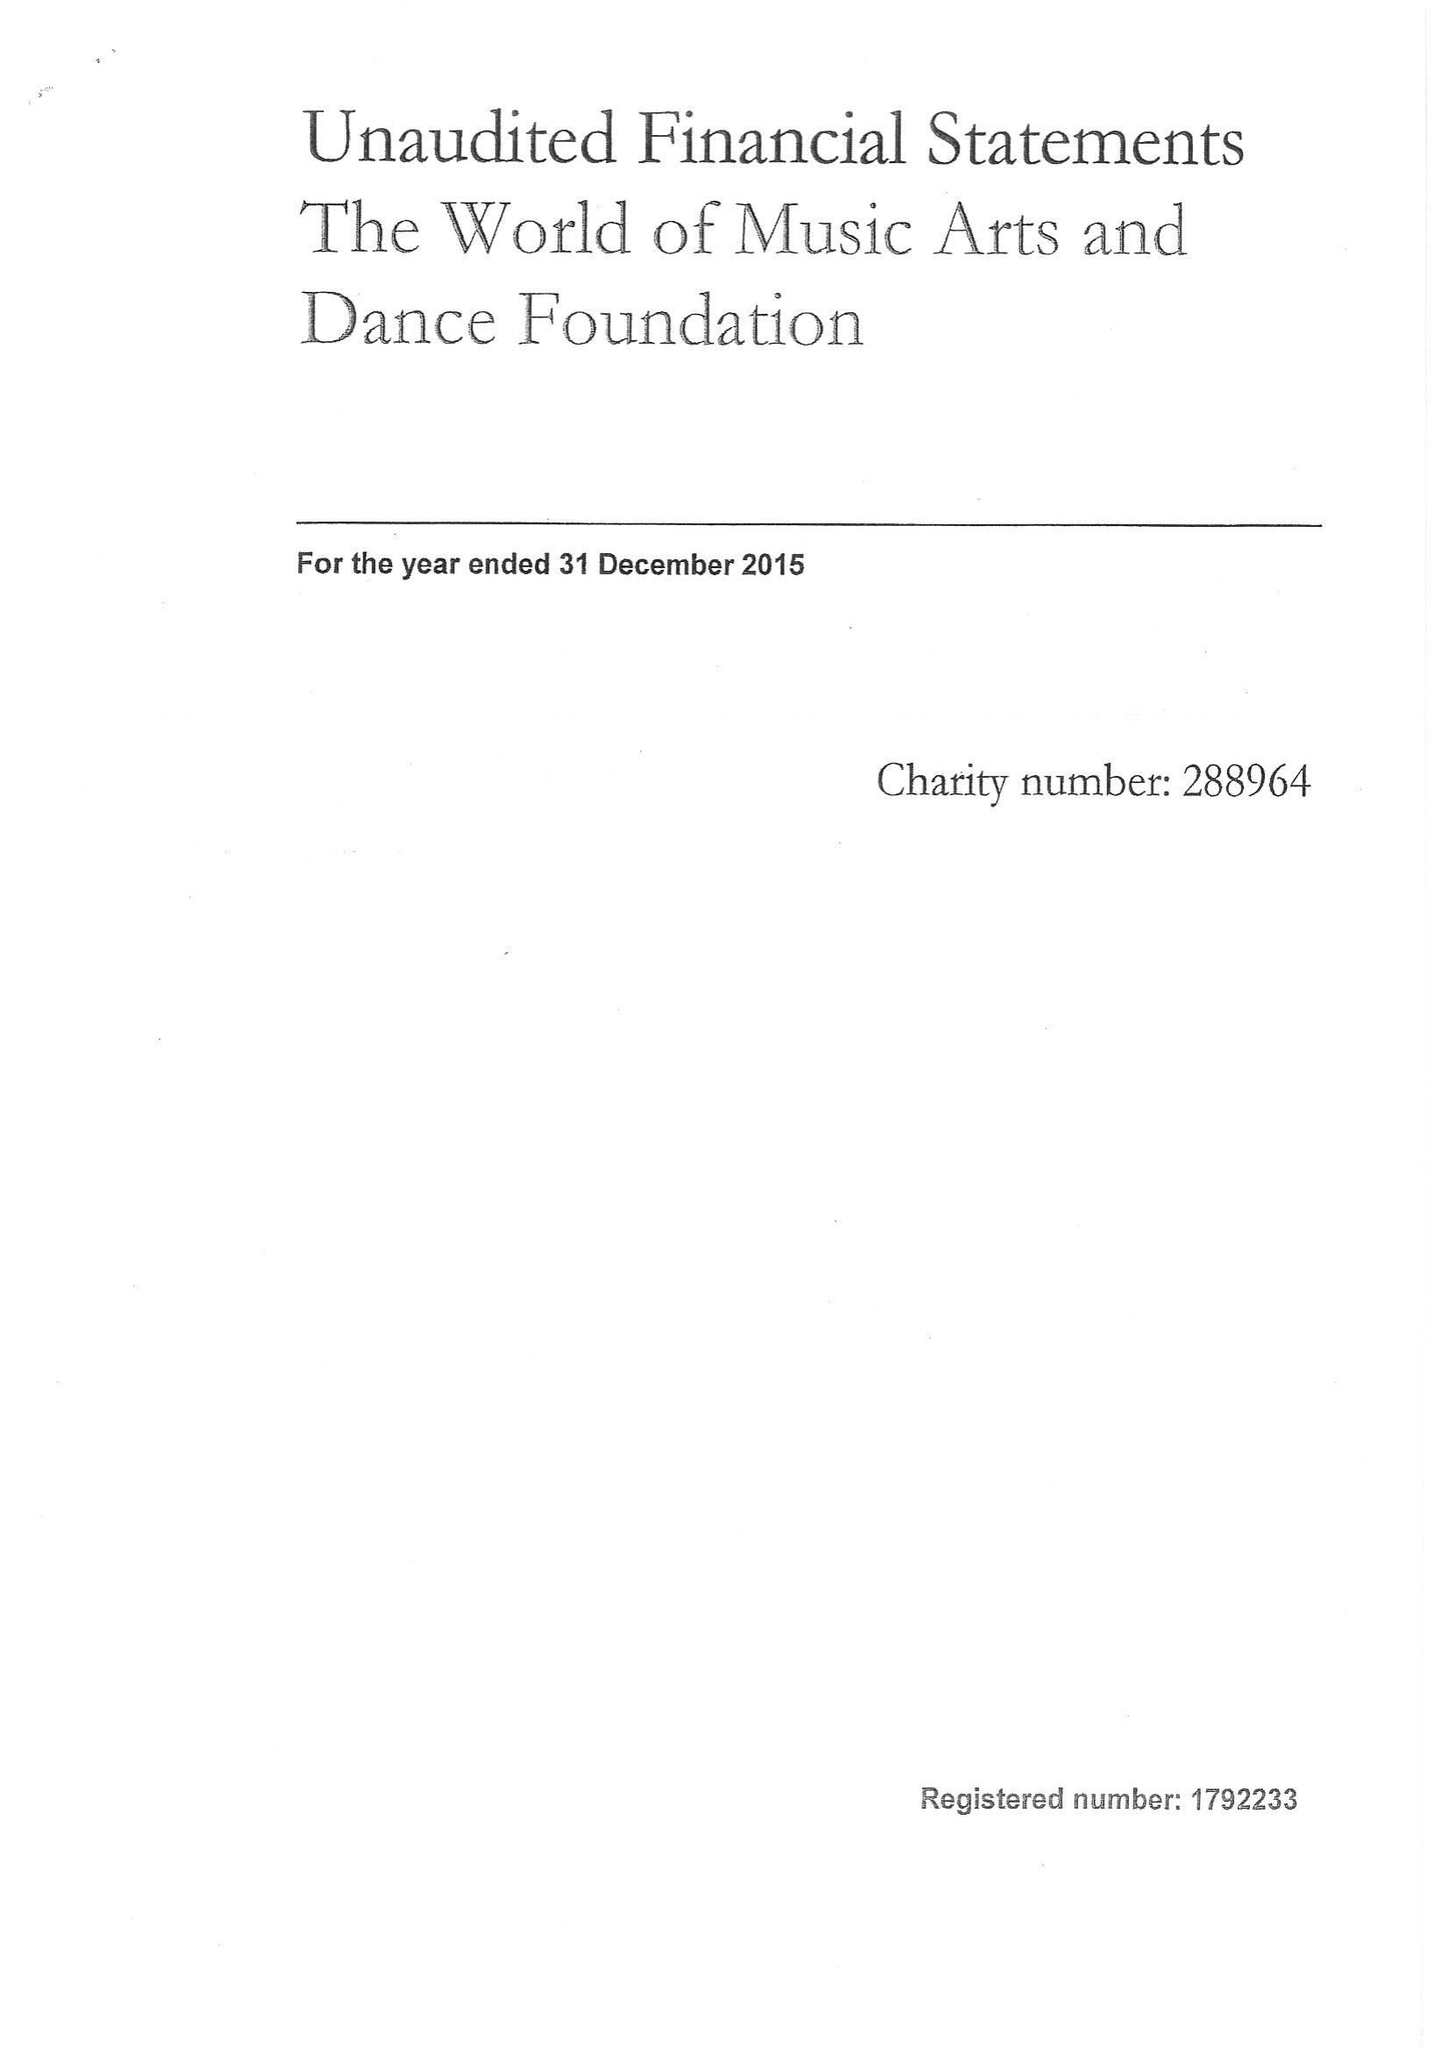What is the value for the address__postcode?
Answer the question using a single word or phrase. SN13 8PN 